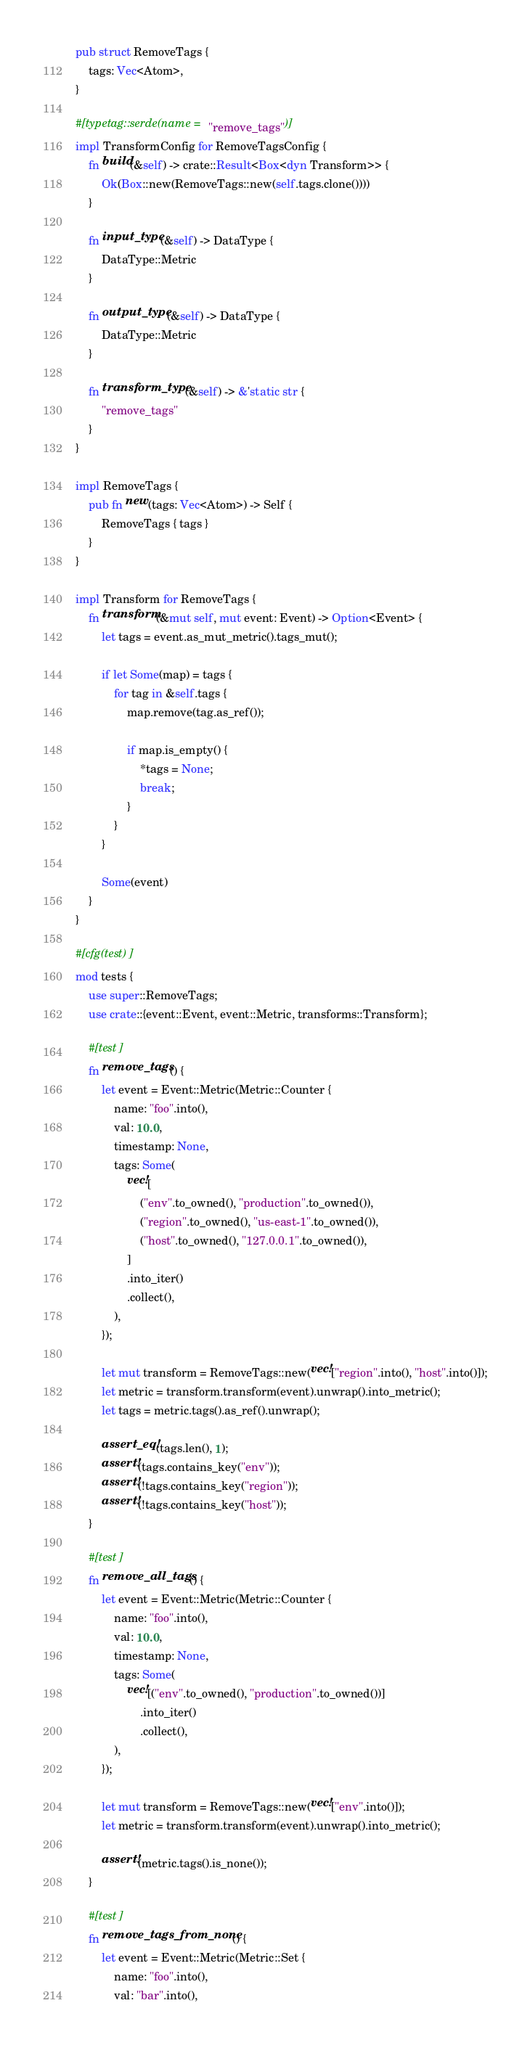<code> <loc_0><loc_0><loc_500><loc_500><_Rust_>pub struct RemoveTags {
    tags: Vec<Atom>,
}

#[typetag::serde(name = "remove_tags")]
impl TransformConfig for RemoveTagsConfig {
    fn build(&self) -> crate::Result<Box<dyn Transform>> {
        Ok(Box::new(RemoveTags::new(self.tags.clone())))
    }

    fn input_type(&self) -> DataType {
        DataType::Metric
    }

    fn output_type(&self) -> DataType {
        DataType::Metric
    }

    fn transform_type(&self) -> &'static str {
        "remove_tags"
    }
}

impl RemoveTags {
    pub fn new(tags: Vec<Atom>) -> Self {
        RemoveTags { tags }
    }
}

impl Transform for RemoveTags {
    fn transform(&mut self, mut event: Event) -> Option<Event> {
        let tags = event.as_mut_metric().tags_mut();

        if let Some(map) = tags {
            for tag in &self.tags {
                map.remove(tag.as_ref());

                if map.is_empty() {
                    *tags = None;
                    break;
                }
            }
        }

        Some(event)
    }
}

#[cfg(test)]
mod tests {
    use super::RemoveTags;
    use crate::{event::Event, event::Metric, transforms::Transform};

    #[test]
    fn remove_tags() {
        let event = Event::Metric(Metric::Counter {
            name: "foo".into(),
            val: 10.0,
            timestamp: None,
            tags: Some(
                vec![
                    ("env".to_owned(), "production".to_owned()),
                    ("region".to_owned(), "us-east-1".to_owned()),
                    ("host".to_owned(), "127.0.0.1".to_owned()),
                ]
                .into_iter()
                .collect(),
            ),
        });

        let mut transform = RemoveTags::new(vec!["region".into(), "host".into()]);
        let metric = transform.transform(event).unwrap().into_metric();
        let tags = metric.tags().as_ref().unwrap();

        assert_eq!(tags.len(), 1);
        assert!(tags.contains_key("env"));
        assert!(!tags.contains_key("region"));
        assert!(!tags.contains_key("host"));
    }

    #[test]
    fn remove_all_tags() {
        let event = Event::Metric(Metric::Counter {
            name: "foo".into(),
            val: 10.0,
            timestamp: None,
            tags: Some(
                vec![("env".to_owned(), "production".to_owned())]
                    .into_iter()
                    .collect(),
            ),
        });

        let mut transform = RemoveTags::new(vec!["env".into()]);
        let metric = transform.transform(event).unwrap().into_metric();

        assert!(metric.tags().is_none());
    }

    #[test]
    fn remove_tags_from_none() {
        let event = Event::Metric(Metric::Set {
            name: "foo".into(),
            val: "bar".into(),</code> 